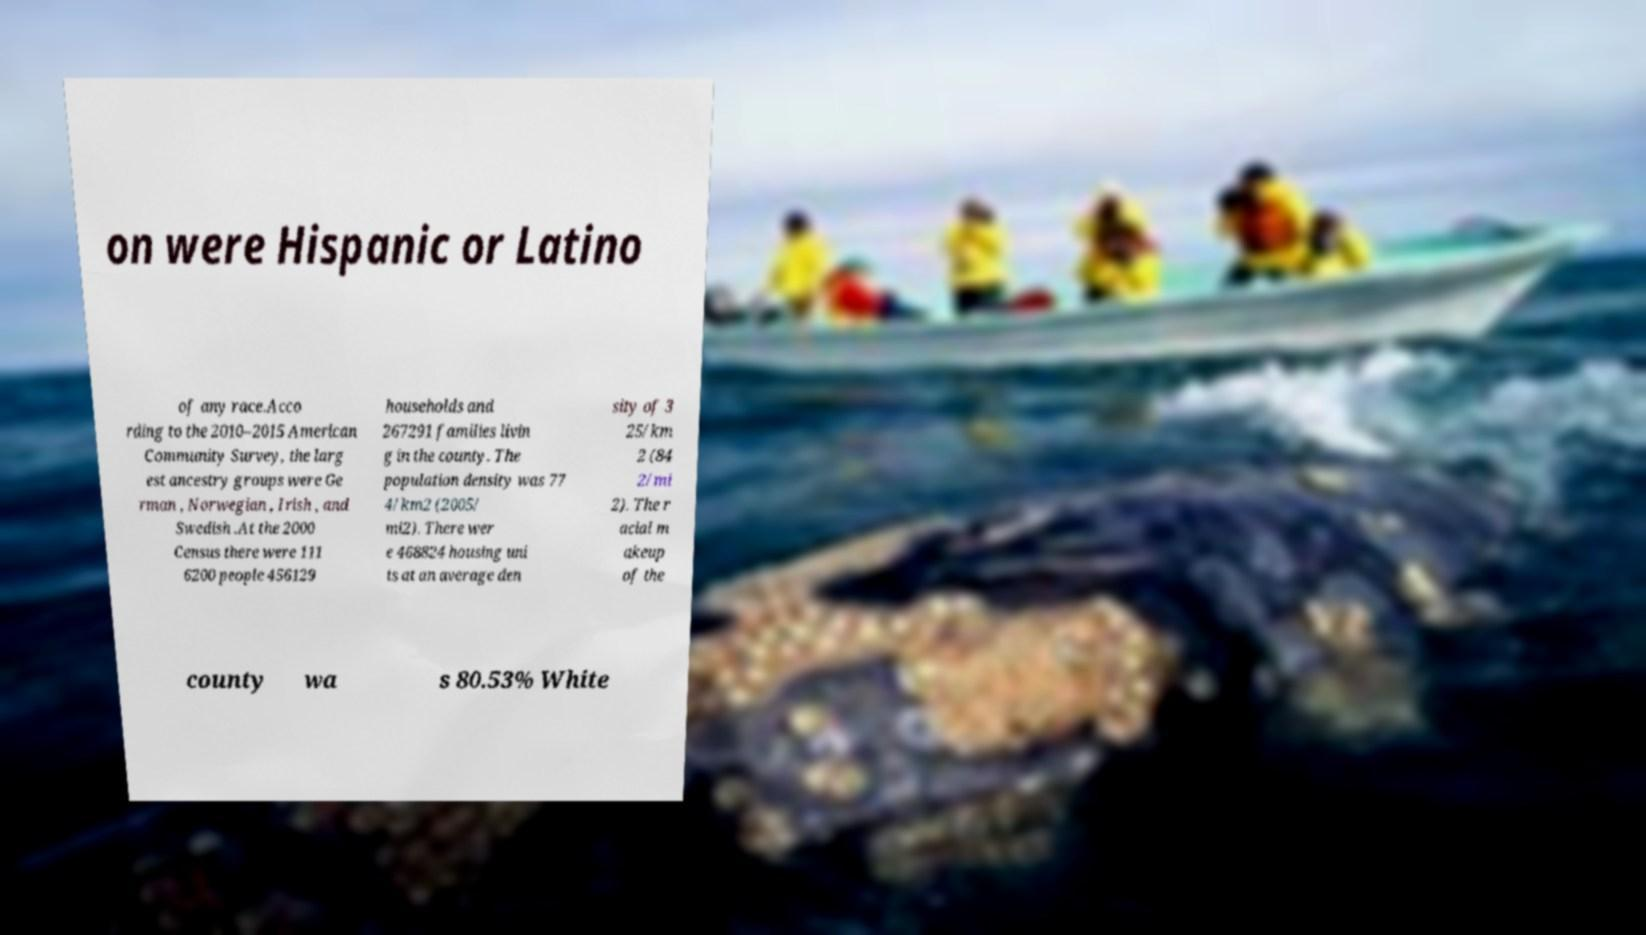Can you accurately transcribe the text from the provided image for me? on were Hispanic or Latino of any race.Acco rding to the 2010–2015 American Community Survey, the larg est ancestry groups were Ge rman , Norwegian , Irish , and Swedish .At the 2000 Census there were 111 6200 people 456129 households and 267291 families livin g in the county. The population density was 77 4/km2 (2005/ mi2). There wer e 468824 housing uni ts at an average den sity of 3 25/km 2 (84 2/mi 2). The r acial m akeup of the county wa s 80.53% White 